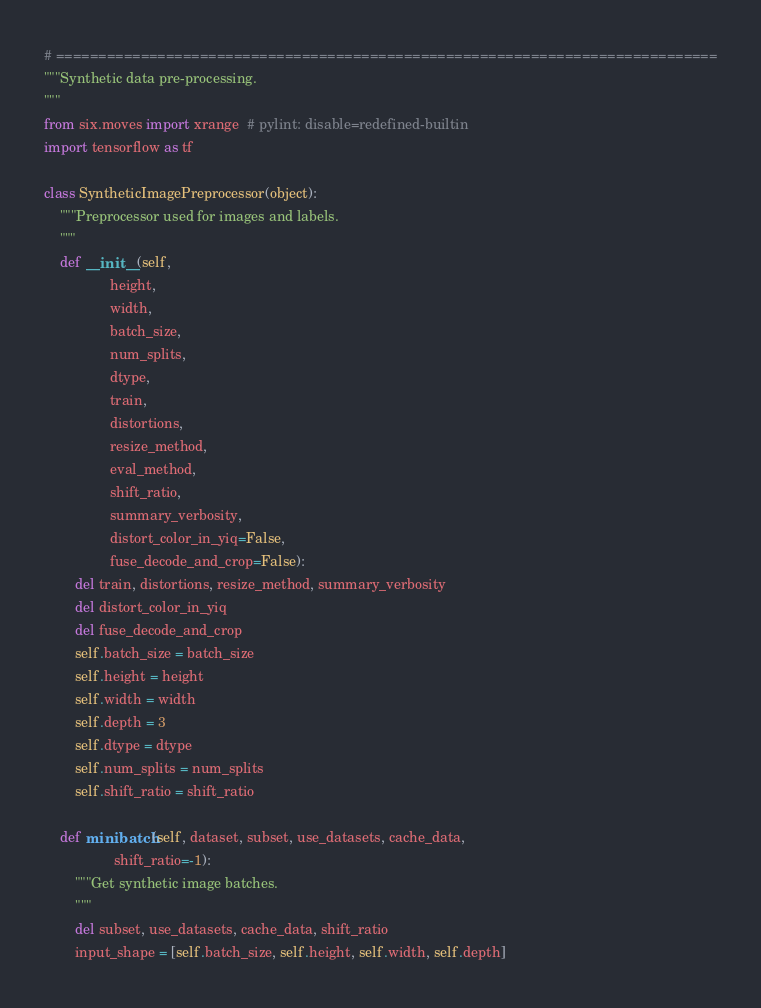Convert code to text. <code><loc_0><loc_0><loc_500><loc_500><_Python_># ==============================================================================
"""Synthetic data pre-processing.
"""
from six.moves import xrange  # pylint: disable=redefined-builtin
import tensorflow as tf

class SyntheticImagePreprocessor(object):
    """Preprocessor used for images and labels.
    """
    def __init__(self,
                 height,
                 width,
                 batch_size,
                 num_splits,
                 dtype,
                 train,
                 distortions,
                 resize_method,
                 eval_method,
                 shift_ratio,
                 summary_verbosity,
                 distort_color_in_yiq=False,
                 fuse_decode_and_crop=False):
        del train, distortions, resize_method, summary_verbosity
        del distort_color_in_yiq
        del fuse_decode_and_crop
        self.batch_size = batch_size
        self.height = height
        self.width = width
        self.depth = 3
        self.dtype = dtype
        self.num_splits = num_splits
        self.shift_ratio = shift_ratio

    def minibatch(self, dataset, subset, use_datasets, cache_data,
                  shift_ratio=-1):
        """Get synthetic image batches.
        """
        del subset, use_datasets, cache_data, shift_ratio
        input_shape = [self.batch_size, self.height, self.width, self.depth]</code> 